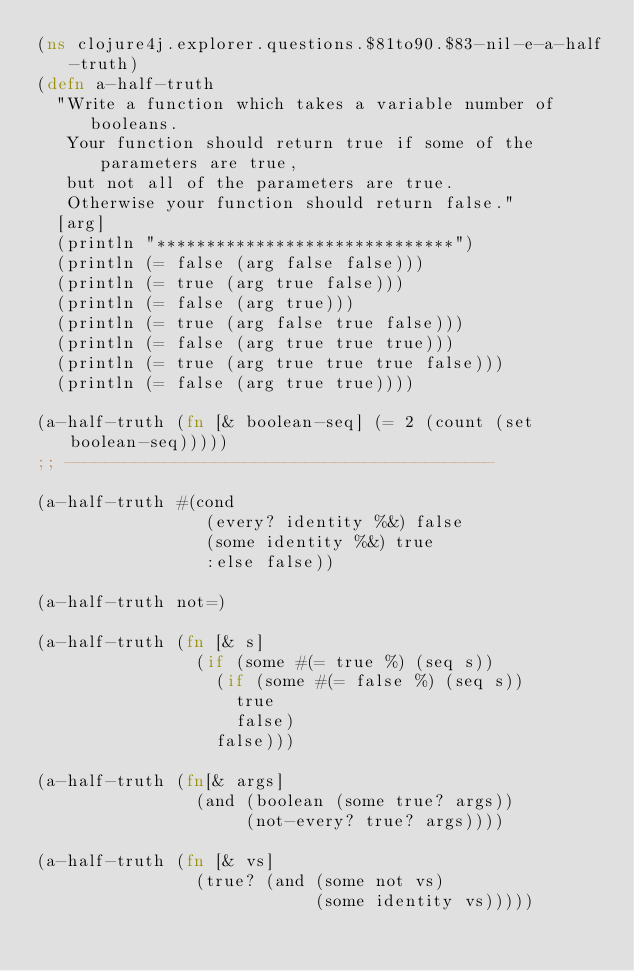<code> <loc_0><loc_0><loc_500><loc_500><_Clojure_>(ns clojure4j.explorer.questions.$81to90.$83-nil-e-a-half-truth)
(defn a-half-truth
  "Write a function which takes a variable number of booleans.
   Your function should return true if some of the parameters are true,
   but not all of the parameters are true.
   Otherwise your function should return false."
  [arg]
  (println "******************************")
  (println (= false (arg false false)))
  (println (= true (arg true false)))
  (println (= false (arg true)))
  (println (= true (arg false true false)))
  (println (= false (arg true true true)))
  (println (= true (arg true true true false)))
  (println (= false (arg true true))))

(a-half-truth (fn [& boolean-seq] (= 2 (count (set boolean-seq)))))
;; -------------------------------------------

(a-half-truth #(cond
                 (every? identity %&) false
                 (some identity %&) true
                 :else false))

(a-half-truth not=)

(a-half-truth (fn [& s]
                (if (some #(= true %) (seq s))
                  (if (some #(= false %) (seq s))
                    true
                    false)
                  false)))

(a-half-truth (fn[& args]
                (and (boolean (some true? args))
                     (not-every? true? args))))

(a-half-truth (fn [& vs]
                (true? (and (some not vs)
                            (some identity vs)))))</code> 